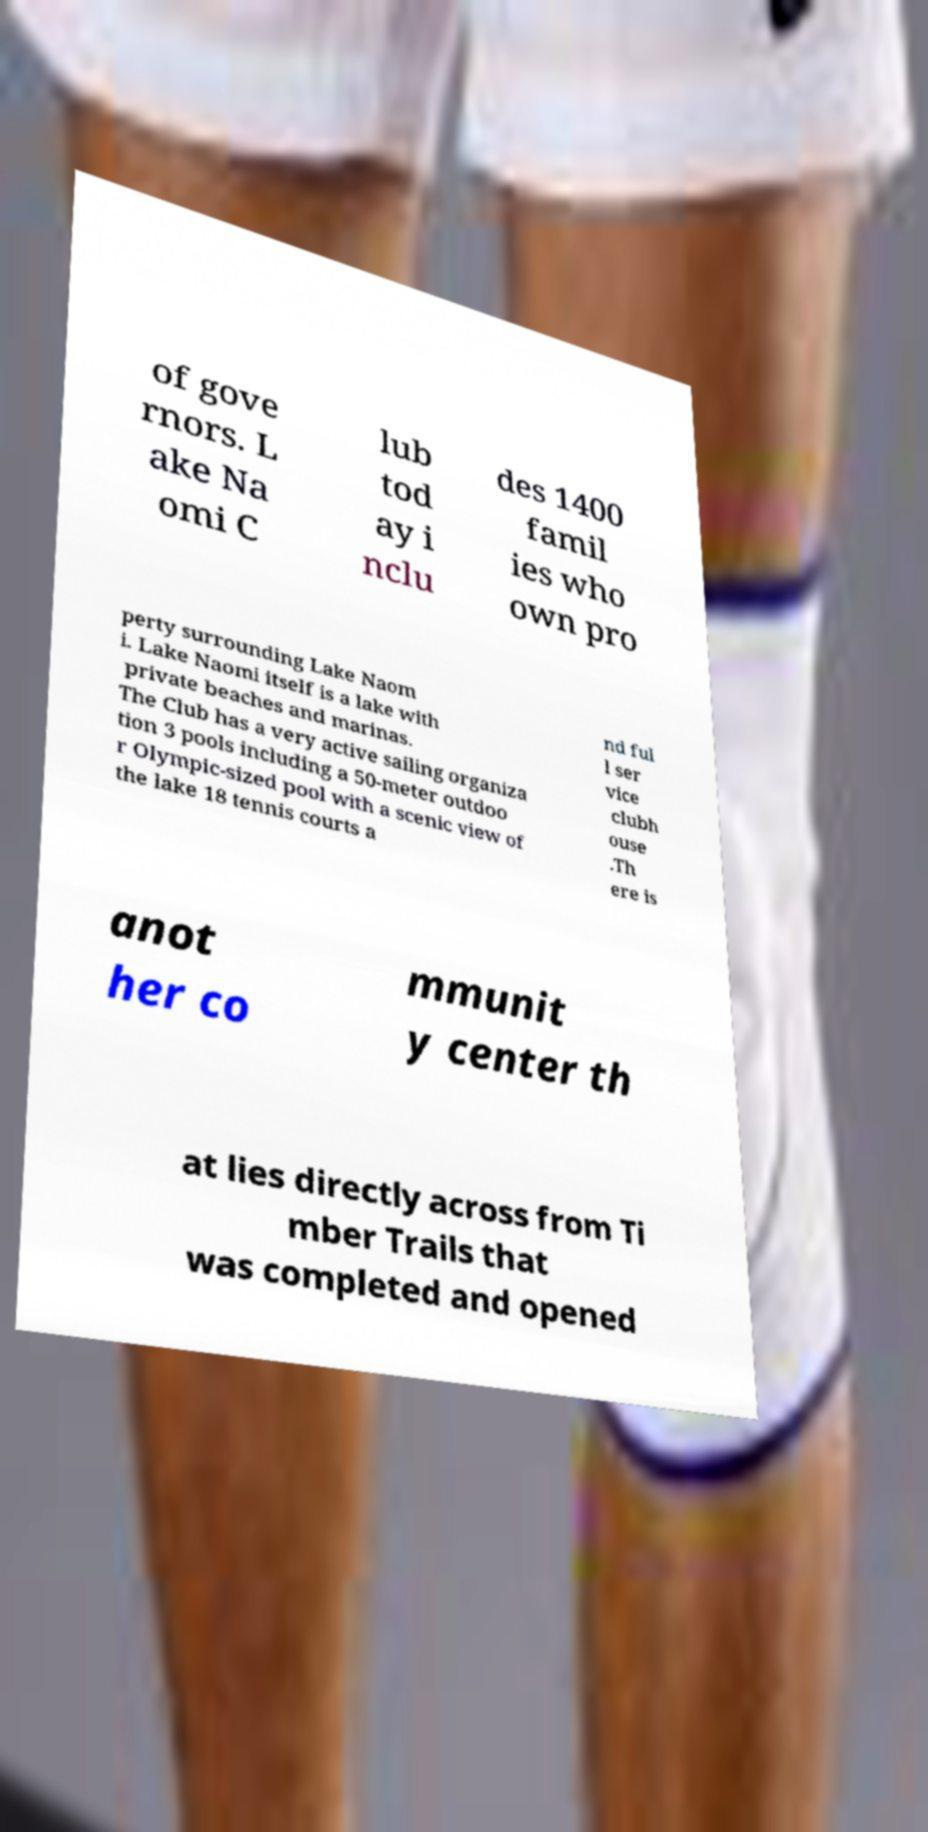Please read and relay the text visible in this image. What does it say? of gove rnors. L ake Na omi C lub tod ay i nclu des 1400 famil ies who own pro perty surrounding Lake Naom i. Lake Naomi itself is a lake with private beaches and marinas. The Club has a very active sailing organiza tion 3 pools including a 50-meter outdoo r Olympic-sized pool with a scenic view of the lake 18 tennis courts a nd ful l ser vice clubh ouse .Th ere is anot her co mmunit y center th at lies directly across from Ti mber Trails that was completed and opened 